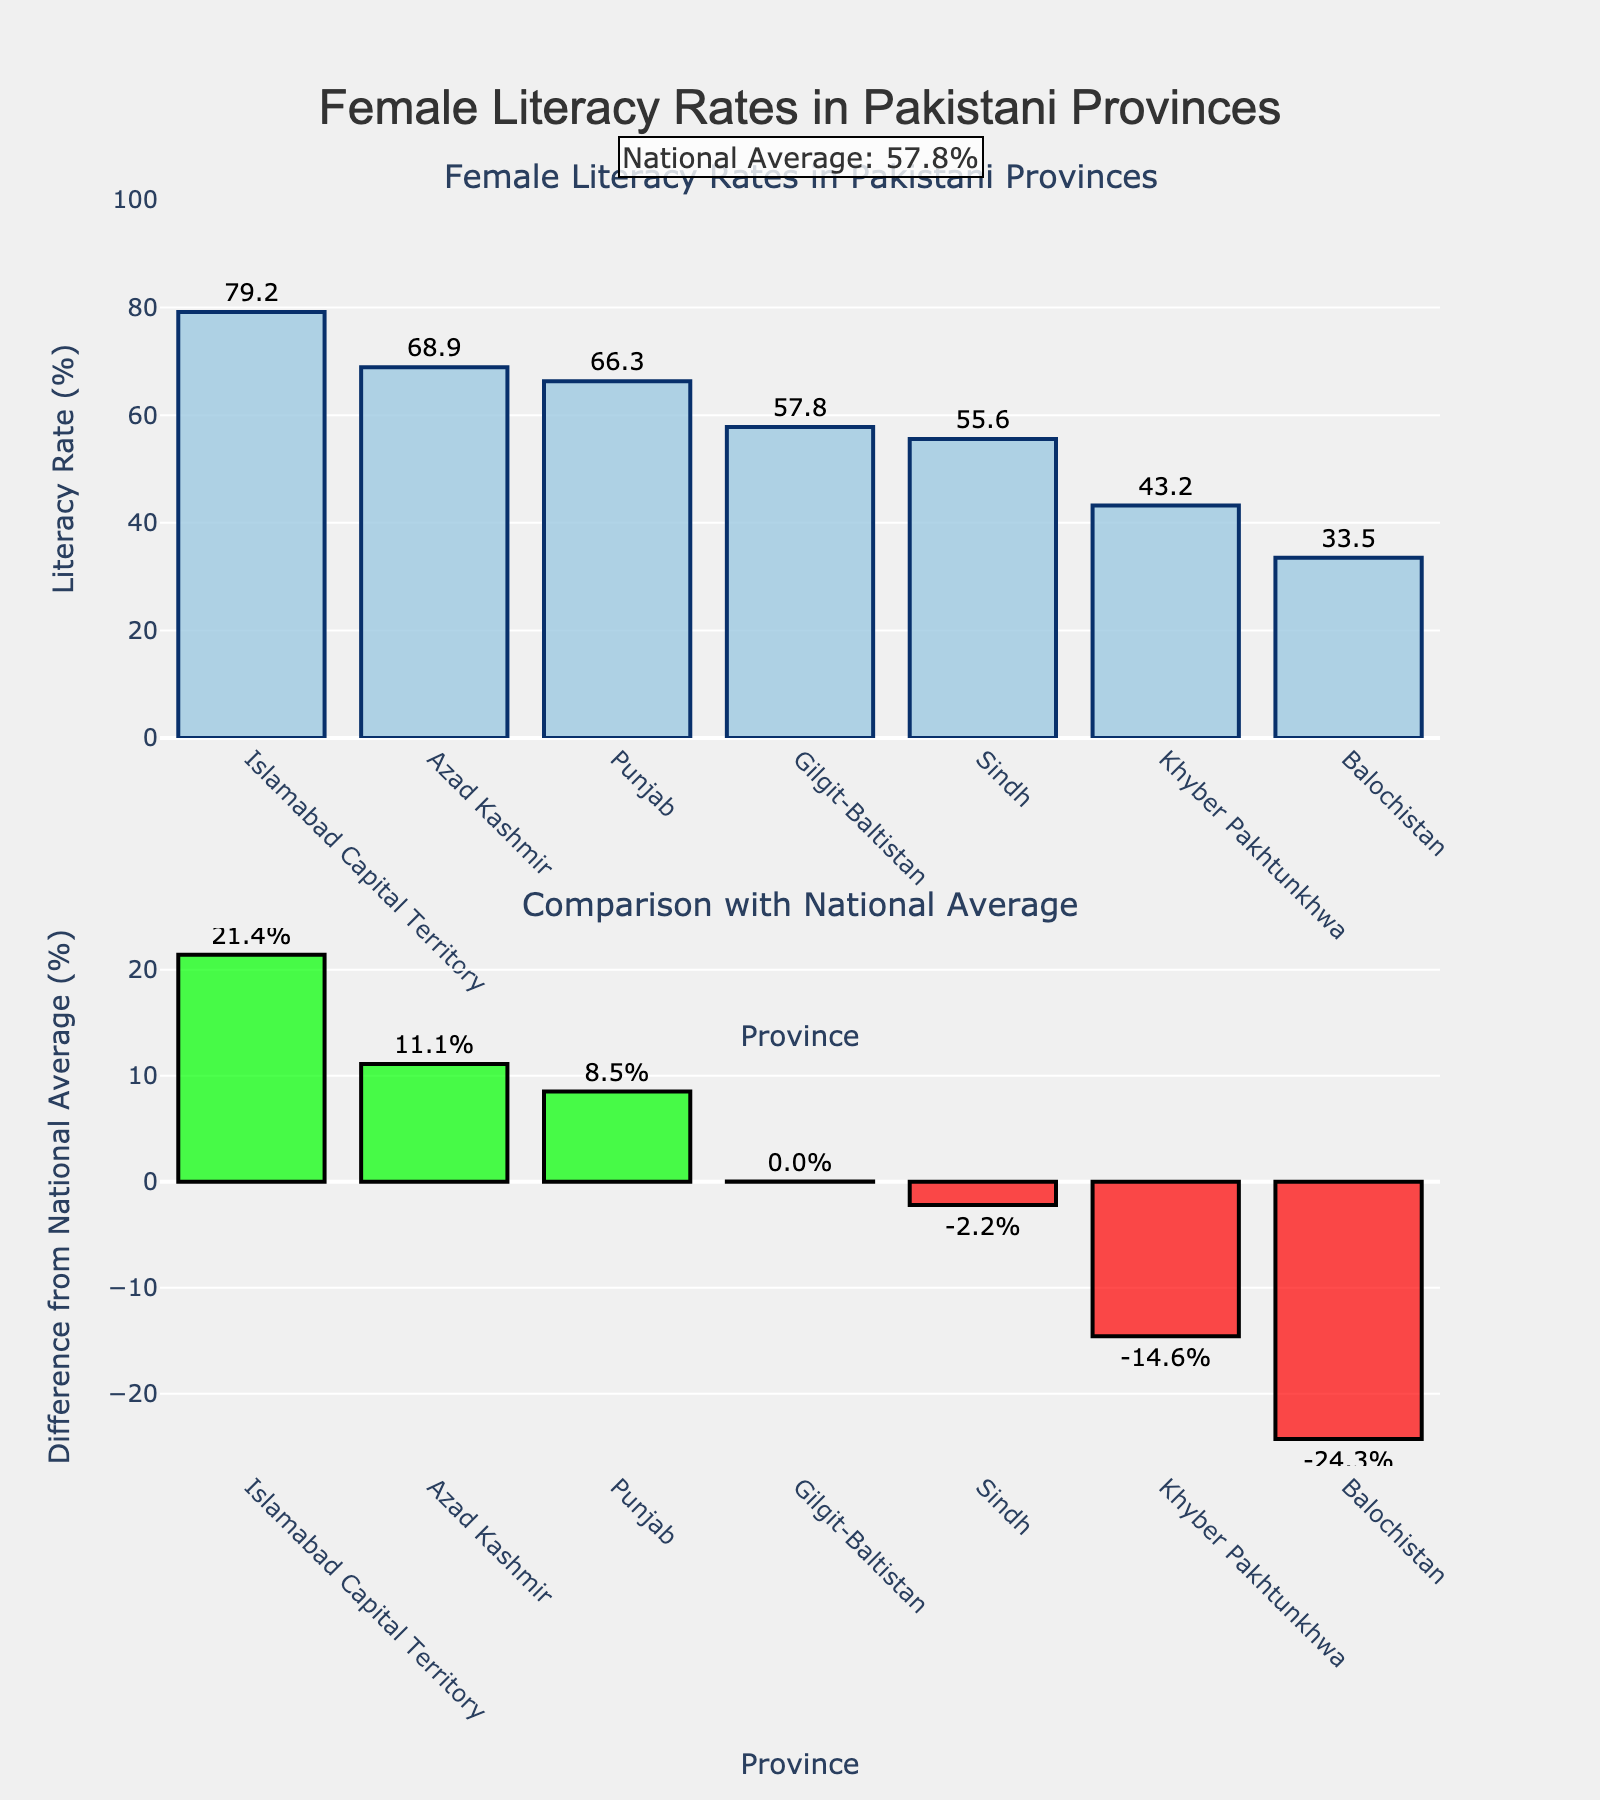Which province has the highest female literacy rate? The highest bar in the top subplot represents Islamabad Capital Territory with a literacy rate of 79.2%.
Answer: Islamabad Capital Territory How does the female literacy rate in Balochistan compare to the national average? The bottom subplot indicates how each province's literacy rate deviates from the national average. The bar for Balochistan is below zero, meaning its literacy rate (33.5%) is below the national average.
Answer: Below What is the national average female literacy rate? The annotation above the second subplot indicates the national average, which is 57.8%.
Answer: 57.8% Which provinces have a literacy rate above the national average? The bottom subplot shows positive bars for provinces with rates above the national average. These provinces include Islamabad Capital Territory, Azad Kashmir, Punjab, and Gilgit-Baltistan.
Answer: Islamabad Capital Territory, Azad Kashmir, Punjab, Gilgit-Baltistan What is the difference between the female literacy rates of Sindh and Punjab? The top subplot shows that Sindh has a literacy rate of 55.6% and Punjab has 66.3%. The difference is calculated by subtracting the rate of Sindh from that of Punjab.
Answer: 10.7% Which province has the lowest female literacy rate? The top subplot bar for Balochistan is the shortest, indicating it has the lowest literacy rate at 33.5%.
Answer: Balochistan How many provinces have female literacy rates below the national average? The bottom subplot shows four bars below the zero line, indicating four provinces (Sindh, Khyber Pakhtunkhwa, Balochistan, and Gilgit-Baltistan) are below the national average.
Answer: 4 By how much does the female literacy rate in Azad Kashmir exceed the national average? The bottom subplot shows the positive bar for Azad Kashmir, indicating it exceeds the national average by 11.1%.
Answer: 11.1% Is the literacy rate of Khyber Pakhtunkhwa more or less than that of Sindh? The top subplot shows Khyber Pakhtunkhwa with a literacy rate of 43.2% and Sindh with 55.6%, indicating Khyber Pakhtunkhwa has a lower rate.
Answer: Less What is the range of female literacy rates among all provinces? The range is calculated by subtracting the lowest value (Balochistan, 33.5%) from the highest value (Islamabad Capital Territory, 79.2%).
Answer: 45.7% 